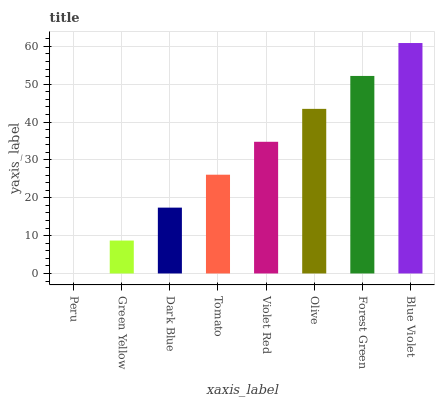Is Green Yellow the minimum?
Answer yes or no. No. Is Green Yellow the maximum?
Answer yes or no. No. Is Green Yellow greater than Peru?
Answer yes or no. Yes. Is Peru less than Green Yellow?
Answer yes or no. Yes. Is Peru greater than Green Yellow?
Answer yes or no. No. Is Green Yellow less than Peru?
Answer yes or no. No. Is Violet Red the high median?
Answer yes or no. Yes. Is Tomato the low median?
Answer yes or no. Yes. Is Tomato the high median?
Answer yes or no. No. Is Blue Violet the low median?
Answer yes or no. No. 